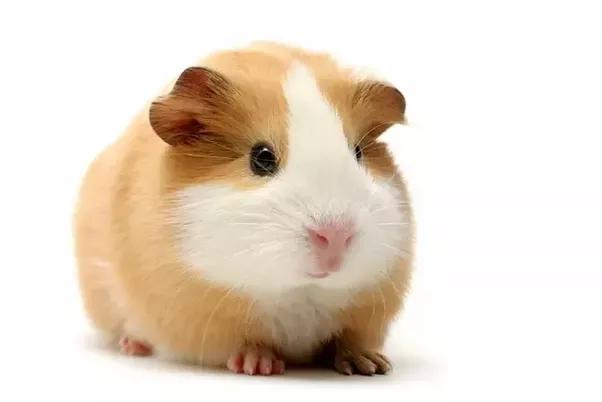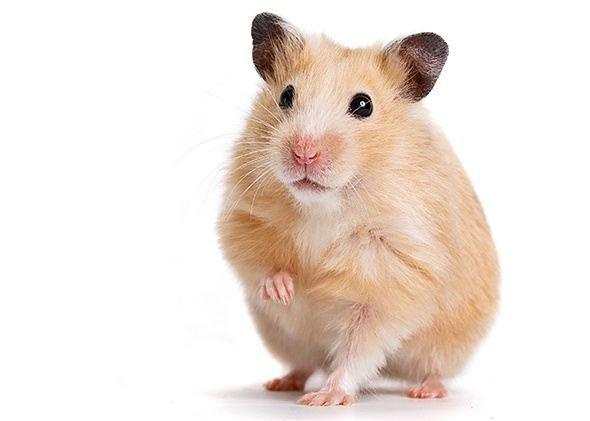The first image is the image on the left, the second image is the image on the right. For the images shown, is this caption "A total of three rodent-type pets are shown." true? Answer yes or no. No. 